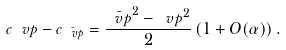<formula> <loc_0><loc_0><loc_500><loc_500>c _ { \ } v p - c _ { \bar { \ v p } } = \frac { \bar { \ v p } ^ { 2 } - \ v p ^ { 2 } } 2 \left ( 1 + O ( \alpha ) \right ) .</formula> 